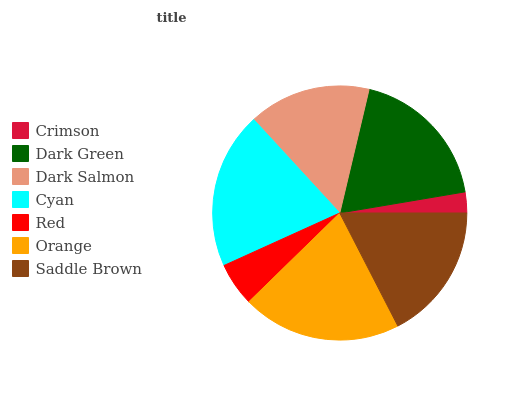Is Crimson the minimum?
Answer yes or no. Yes. Is Orange the maximum?
Answer yes or no. Yes. Is Dark Green the minimum?
Answer yes or no. No. Is Dark Green the maximum?
Answer yes or no. No. Is Dark Green greater than Crimson?
Answer yes or no. Yes. Is Crimson less than Dark Green?
Answer yes or no. Yes. Is Crimson greater than Dark Green?
Answer yes or no. No. Is Dark Green less than Crimson?
Answer yes or no. No. Is Saddle Brown the high median?
Answer yes or no. Yes. Is Saddle Brown the low median?
Answer yes or no. Yes. Is Cyan the high median?
Answer yes or no. No. Is Dark Salmon the low median?
Answer yes or no. No. 